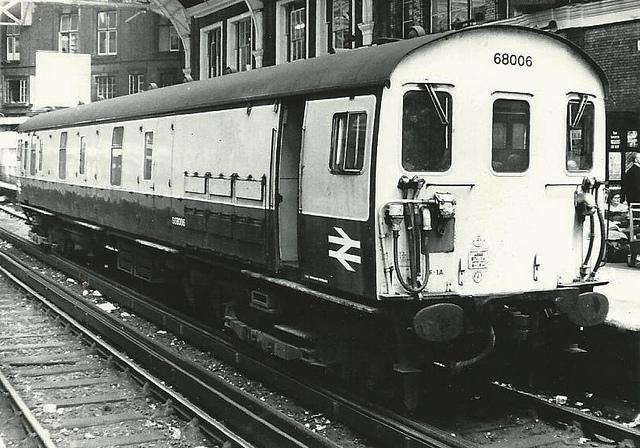Is this picture old?
Be succinct. Yes. What does this car carry?
Write a very short answer. People. What is the number on this train?
Answer briefly. 68006. 